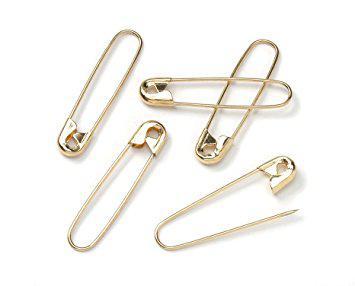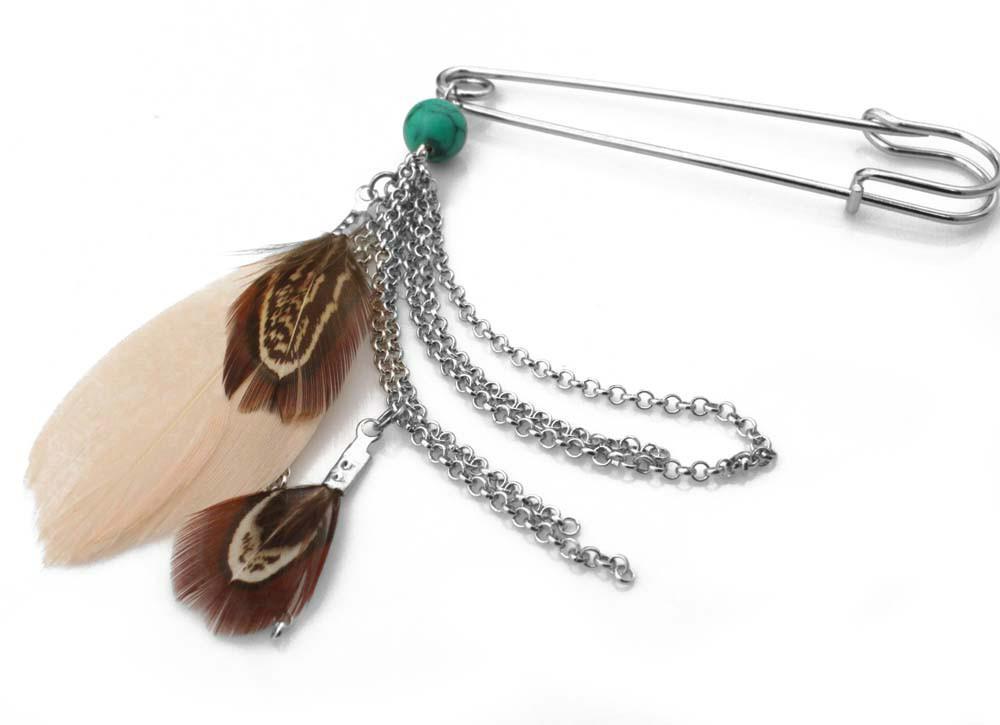The first image is the image on the left, the second image is the image on the right. Examine the images to the left and right. Is the description "There is a feather in one of the images." accurate? Answer yes or no. Yes. 